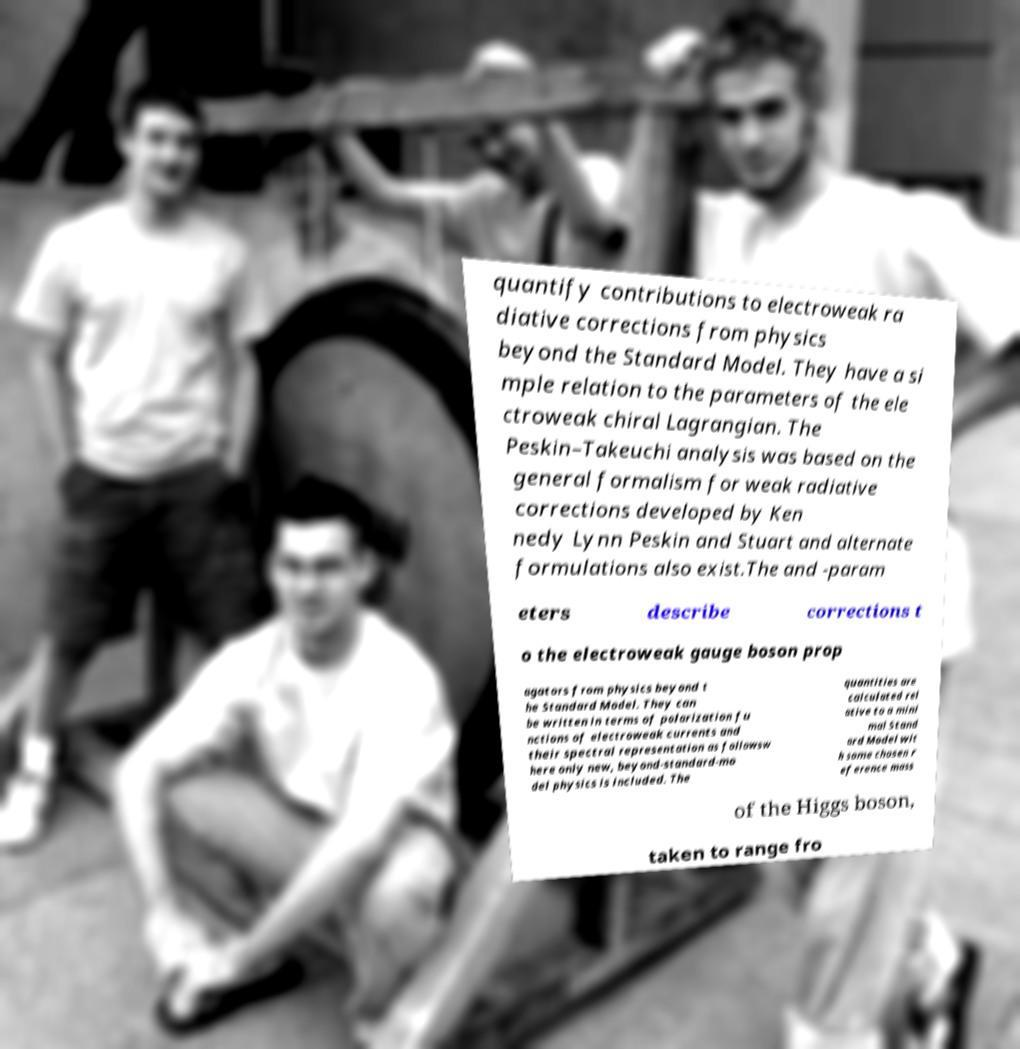Could you extract and type out the text from this image? quantify contributions to electroweak ra diative corrections from physics beyond the Standard Model. They have a si mple relation to the parameters of the ele ctroweak chiral Lagrangian. The Peskin–Takeuchi analysis was based on the general formalism for weak radiative corrections developed by Ken nedy Lynn Peskin and Stuart and alternate formulations also exist.The and -param eters describe corrections t o the electroweak gauge boson prop agators from physics beyond t he Standard Model. They can be written in terms of polarization fu nctions of electroweak currents and their spectral representation as followsw here only new, beyond-standard-mo del physics is included. The quantities are calculated rel ative to a mini mal Stand ard Model wit h some chosen r eference mass of the Higgs boson, taken to range fro 